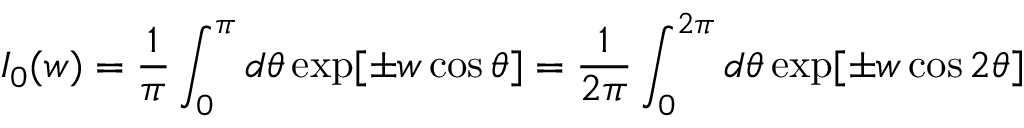<formula> <loc_0><loc_0><loc_500><loc_500>I _ { 0 } ( w ) = \frac { 1 } { \pi } \int _ { 0 } ^ { \pi } d \theta \exp [ \pm w \cos \theta ] = \frac { 1 } { 2 \pi } \int _ { 0 } ^ { 2 \pi } d \theta \exp [ \pm w \cos 2 \theta ]</formula> 